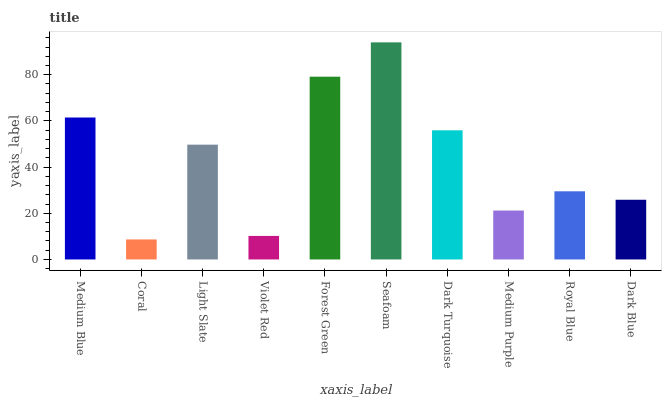Is Light Slate the minimum?
Answer yes or no. No. Is Light Slate the maximum?
Answer yes or no. No. Is Light Slate greater than Coral?
Answer yes or no. Yes. Is Coral less than Light Slate?
Answer yes or no. Yes. Is Coral greater than Light Slate?
Answer yes or no. No. Is Light Slate less than Coral?
Answer yes or no. No. Is Light Slate the high median?
Answer yes or no. Yes. Is Royal Blue the low median?
Answer yes or no. Yes. Is Forest Green the high median?
Answer yes or no. No. Is Dark Turquoise the low median?
Answer yes or no. No. 